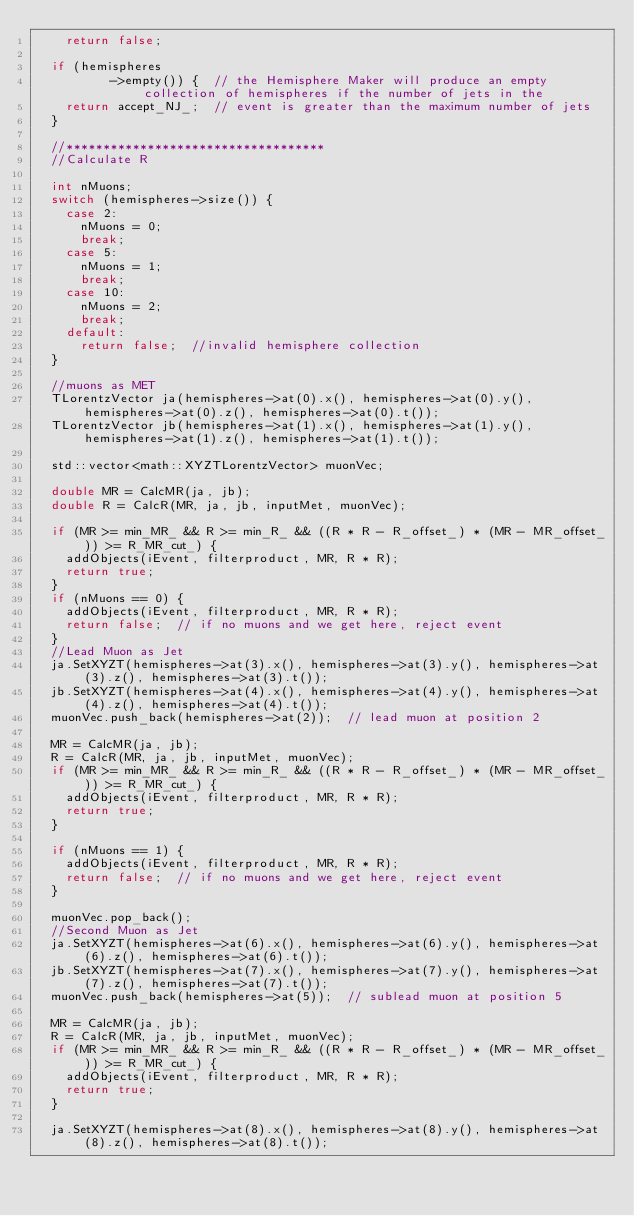Convert code to text. <code><loc_0><loc_0><loc_500><loc_500><_C++_>    return false;

  if (hemispheres
          ->empty()) {  // the Hemisphere Maker will produce an empty collection of hemispheres if the number of jets in the
    return accept_NJ_;  // event is greater than the maximum number of jets
  }

  //***********************************
  //Calculate R

  int nMuons;
  switch (hemispheres->size()) {
    case 2:
      nMuons = 0;
      break;
    case 5:
      nMuons = 1;
      break;
    case 10:
      nMuons = 2;
      break;
    default:
      return false;  //invalid hemisphere collection
  }

  //muons as MET
  TLorentzVector ja(hemispheres->at(0).x(), hemispheres->at(0).y(), hemispheres->at(0).z(), hemispheres->at(0).t());
  TLorentzVector jb(hemispheres->at(1).x(), hemispheres->at(1).y(), hemispheres->at(1).z(), hemispheres->at(1).t());

  std::vector<math::XYZTLorentzVector> muonVec;

  double MR = CalcMR(ja, jb);
  double R = CalcR(MR, ja, jb, inputMet, muonVec);

  if (MR >= min_MR_ && R >= min_R_ && ((R * R - R_offset_) * (MR - MR_offset_)) >= R_MR_cut_) {
    addObjects(iEvent, filterproduct, MR, R * R);
    return true;
  }
  if (nMuons == 0) {
    addObjects(iEvent, filterproduct, MR, R * R);
    return false;  // if no muons and we get here, reject event
  }
  //Lead Muon as Jet
  ja.SetXYZT(hemispheres->at(3).x(), hemispheres->at(3).y(), hemispheres->at(3).z(), hemispheres->at(3).t());
  jb.SetXYZT(hemispheres->at(4).x(), hemispheres->at(4).y(), hemispheres->at(4).z(), hemispheres->at(4).t());
  muonVec.push_back(hemispheres->at(2));  // lead muon at position 2

  MR = CalcMR(ja, jb);
  R = CalcR(MR, ja, jb, inputMet, muonVec);
  if (MR >= min_MR_ && R >= min_R_ && ((R * R - R_offset_) * (MR - MR_offset_)) >= R_MR_cut_) {
    addObjects(iEvent, filterproduct, MR, R * R);
    return true;
  }

  if (nMuons == 1) {
    addObjects(iEvent, filterproduct, MR, R * R);
    return false;  // if no muons and we get here, reject event
  }

  muonVec.pop_back();
  //Second Muon as Jet
  ja.SetXYZT(hemispheres->at(6).x(), hemispheres->at(6).y(), hemispheres->at(6).z(), hemispheres->at(6).t());
  jb.SetXYZT(hemispheres->at(7).x(), hemispheres->at(7).y(), hemispheres->at(7).z(), hemispheres->at(7).t());
  muonVec.push_back(hemispheres->at(5));  // sublead muon at position 5

  MR = CalcMR(ja, jb);
  R = CalcR(MR, ja, jb, inputMet, muonVec);
  if (MR >= min_MR_ && R >= min_R_ && ((R * R - R_offset_) * (MR - MR_offset_)) >= R_MR_cut_) {
    addObjects(iEvent, filterproduct, MR, R * R);
    return true;
  }

  ja.SetXYZT(hemispheres->at(8).x(), hemispheres->at(8).y(), hemispheres->at(8).z(), hemispheres->at(8).t());</code> 